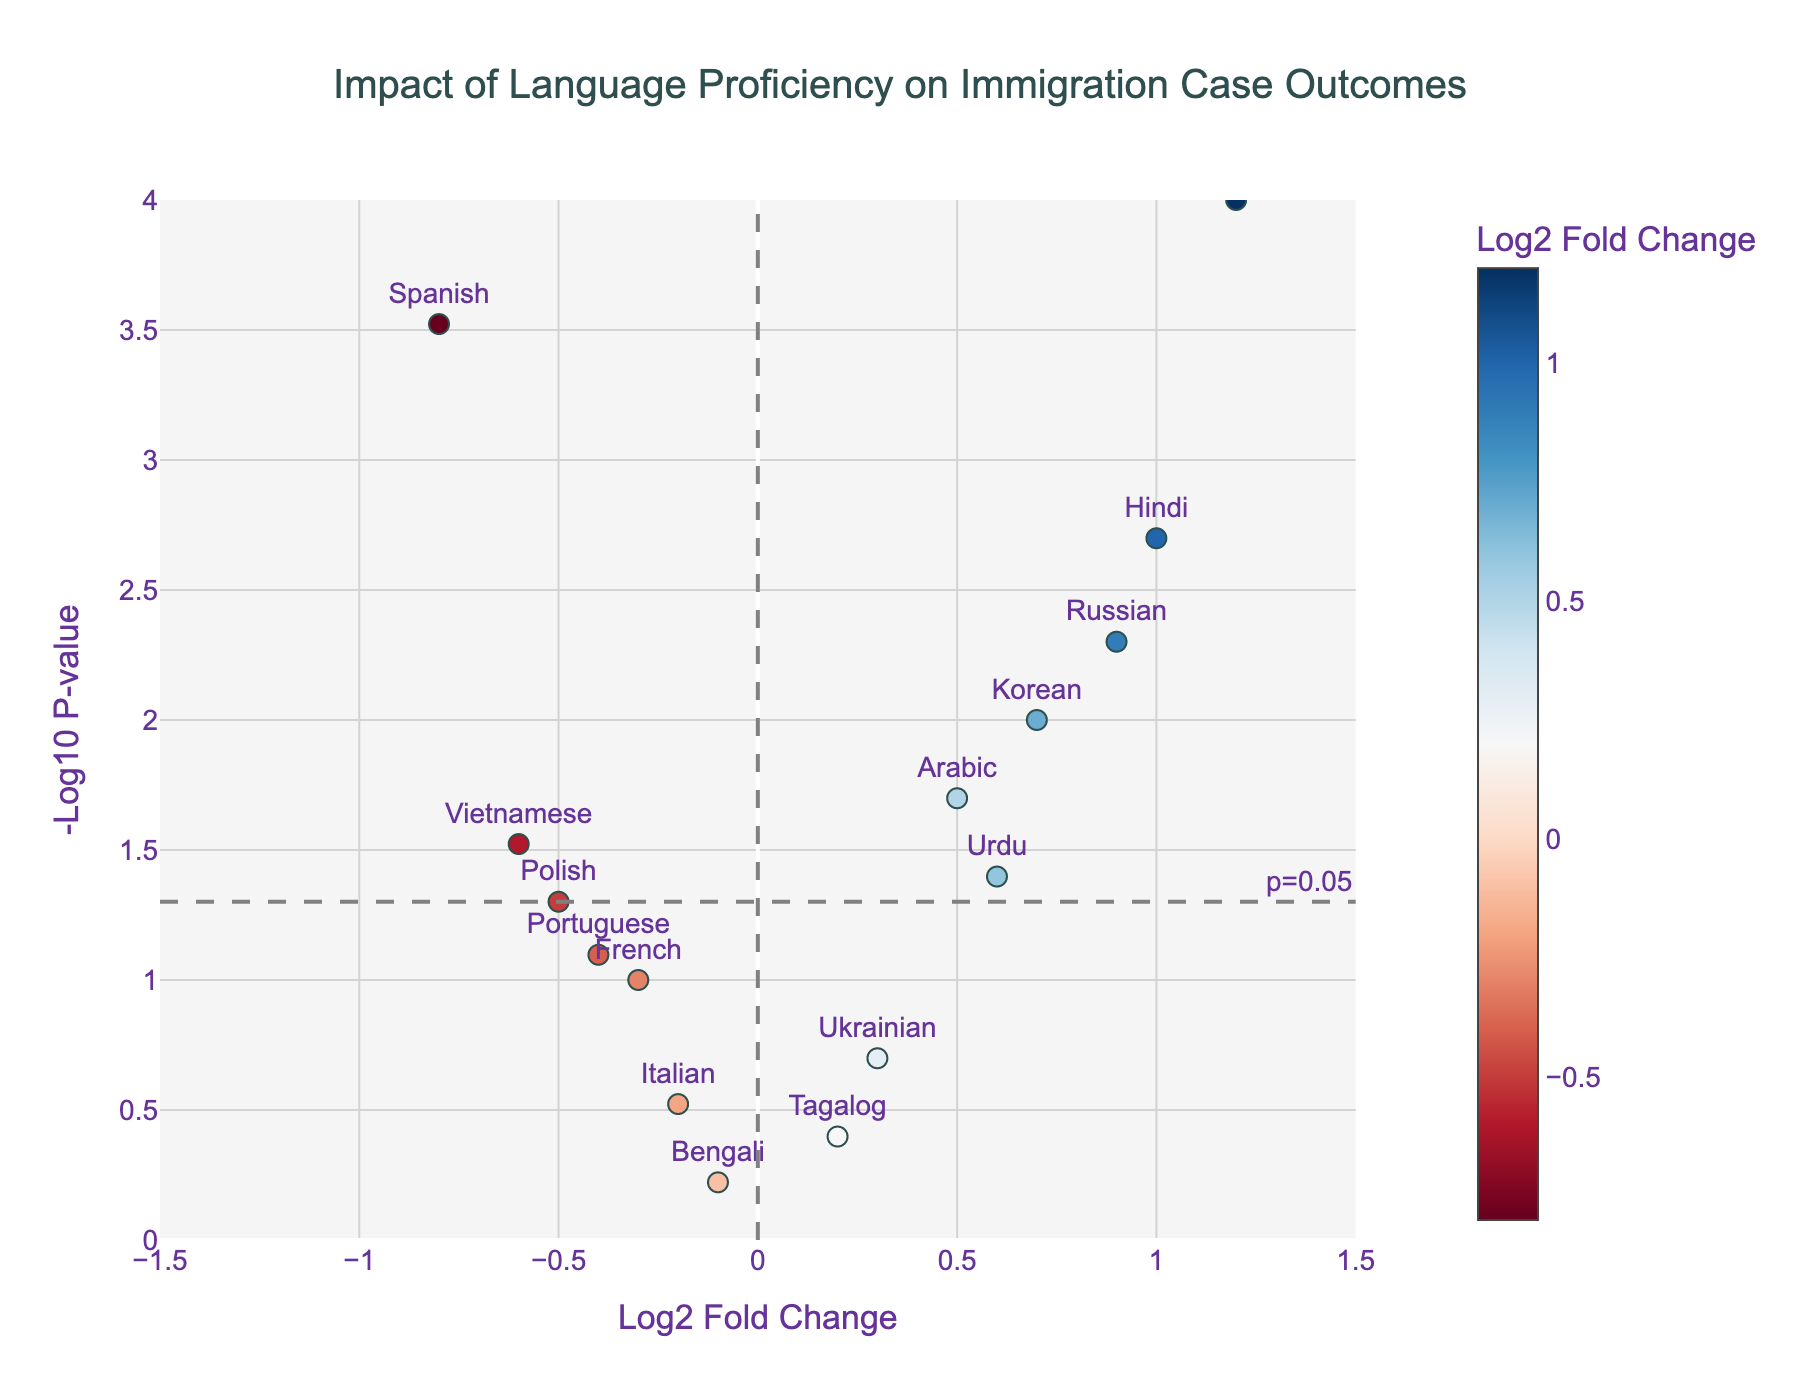what is the title of the plot? The title is typically found at the top of the plot and it provides a concise summary of what the figure represents. Here, the title is "Impact of Language Proficiency on Immigration Case Outcomes"
Answer: Impact of Language Proficiency on Immigration Case Outcomes how many languages have a statistically significant impact on immigration case outcomes? Statistically significant impacts are indicated by p-values less than 0.05. On the plot, this is represented by points above the horizontal line at -log10(p) ≈ 1.3. Counting these points gives the number of languages with significant impacts.
Answer: 8 which language has the highest positive impact on immigration case outcomes? The highest positive impact can be found by looking for the data point with the highest log2 fold change which is greater than zero. According to the plot, the highest value above zero is for Mandarin.
Answer: Mandarin are there any languages with a negative impact and a high level of significance? Languages with negative impacts have negative log2 fold changes. A high level of significance means a small p-value, represented by points far above the horizontal threshold line. From the plot, Spanish and Vietnamese have both negative impacts and high significance.
Answer: Yes, Spanish and Vietnamese which language has the least statistically significant impact on immigration case outcomes? The least statistically significant impact corresponds to the highest p-value, which is depicted as the lowest point on the -log10(p) axis. Bengali has the highest p-value and is the lowest on this axis.
Answer: Bengali how many languages show a positive impact on immigration case outcomes? Positive impacts are indicated by positive log2 fold changes. Count the number of points on the right side of the vertical "Log2 Fold Change = 0" line.
Answer: 8 which language shows a significant impact but has the smallest log2 fold change? "Significant impact" means the p-value is less than 0.05 (points above the horizontal threshold line). To find the smallest log2 fold change among these, we look for the smallest log2 fold change value for these points. French fits this criterion.
Answer: French what is the log2 fold change for Hindi, and is it statistically significant? Locate the data point for Hindi on the plot. The log2 fold change for Hindi is 1.0, and if the point is above the horizontal threshold line (p-value < 0.05), then it's significant.
Answer: 1.0, yes compare the impacts of Russian and Portuguese. Which language has a more significant impact and a higher log2 fold change? Examine the positions of Russian and Portuguese on the plot. Russian has a log2 fold change of 0.9 and is statistically significant, while Portuguese has a log2 fold change of -0.4 and is not statistically significant. Therefore, Russian has both a more significant impact and a higher log2 fold change.
Answer: Russian 